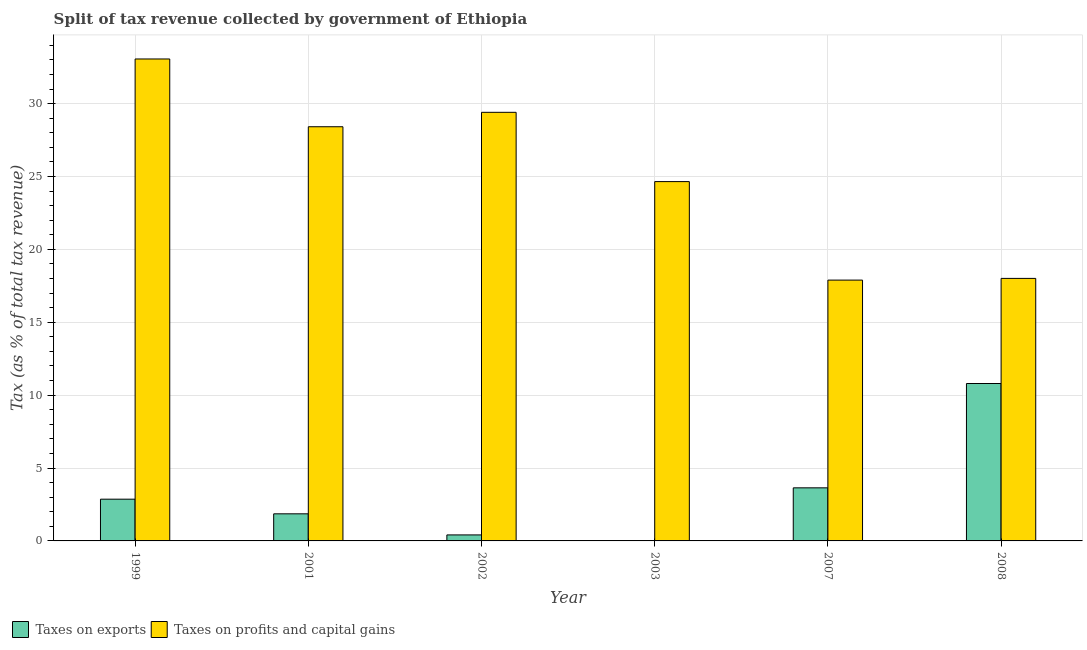How many different coloured bars are there?
Give a very brief answer. 2. Are the number of bars per tick equal to the number of legend labels?
Make the answer very short. Yes. How many bars are there on the 5th tick from the left?
Your response must be concise. 2. In how many cases, is the number of bars for a given year not equal to the number of legend labels?
Provide a succinct answer. 0. What is the percentage of revenue obtained from taxes on exports in 2008?
Keep it short and to the point. 10.8. Across all years, what is the maximum percentage of revenue obtained from taxes on exports?
Provide a short and direct response. 10.8. Across all years, what is the minimum percentage of revenue obtained from taxes on profits and capital gains?
Give a very brief answer. 17.89. In which year was the percentage of revenue obtained from taxes on profits and capital gains maximum?
Your answer should be compact. 1999. In which year was the percentage of revenue obtained from taxes on exports minimum?
Provide a short and direct response. 2003. What is the total percentage of revenue obtained from taxes on exports in the graph?
Keep it short and to the point. 19.59. What is the difference between the percentage of revenue obtained from taxes on exports in 2002 and that in 2007?
Your answer should be compact. -3.23. What is the difference between the percentage of revenue obtained from taxes on exports in 2002 and the percentage of revenue obtained from taxes on profits and capital gains in 2007?
Keep it short and to the point. -3.23. What is the average percentage of revenue obtained from taxes on profits and capital gains per year?
Your response must be concise. 25.24. In the year 2002, what is the difference between the percentage of revenue obtained from taxes on profits and capital gains and percentage of revenue obtained from taxes on exports?
Give a very brief answer. 0. What is the ratio of the percentage of revenue obtained from taxes on exports in 2001 to that in 2003?
Provide a short and direct response. 113.99. Is the difference between the percentage of revenue obtained from taxes on exports in 2002 and 2007 greater than the difference between the percentage of revenue obtained from taxes on profits and capital gains in 2002 and 2007?
Your answer should be very brief. No. What is the difference between the highest and the second highest percentage of revenue obtained from taxes on exports?
Ensure brevity in your answer.  7.16. What is the difference between the highest and the lowest percentage of revenue obtained from taxes on profits and capital gains?
Keep it short and to the point. 15.17. In how many years, is the percentage of revenue obtained from taxes on exports greater than the average percentage of revenue obtained from taxes on exports taken over all years?
Provide a succinct answer. 2. Is the sum of the percentage of revenue obtained from taxes on exports in 2001 and 2007 greater than the maximum percentage of revenue obtained from taxes on profits and capital gains across all years?
Your answer should be compact. No. What does the 1st bar from the left in 2007 represents?
Your response must be concise. Taxes on exports. What does the 2nd bar from the right in 2008 represents?
Your answer should be compact. Taxes on exports. Are all the bars in the graph horizontal?
Offer a terse response. No. Are the values on the major ticks of Y-axis written in scientific E-notation?
Make the answer very short. No. Where does the legend appear in the graph?
Provide a short and direct response. Bottom left. What is the title of the graph?
Offer a terse response. Split of tax revenue collected by government of Ethiopia. Does "From Government" appear as one of the legend labels in the graph?
Your response must be concise. No. What is the label or title of the Y-axis?
Provide a succinct answer. Tax (as % of total tax revenue). What is the Tax (as % of total tax revenue) in Taxes on exports in 1999?
Your answer should be very brief. 2.86. What is the Tax (as % of total tax revenue) in Taxes on profits and capital gains in 1999?
Keep it short and to the point. 33.06. What is the Tax (as % of total tax revenue) of Taxes on exports in 2001?
Offer a terse response. 1.86. What is the Tax (as % of total tax revenue) in Taxes on profits and capital gains in 2001?
Your response must be concise. 28.41. What is the Tax (as % of total tax revenue) in Taxes on exports in 2002?
Your answer should be very brief. 0.41. What is the Tax (as % of total tax revenue) in Taxes on profits and capital gains in 2002?
Offer a very short reply. 29.4. What is the Tax (as % of total tax revenue) in Taxes on exports in 2003?
Your answer should be compact. 0.02. What is the Tax (as % of total tax revenue) of Taxes on profits and capital gains in 2003?
Ensure brevity in your answer.  24.65. What is the Tax (as % of total tax revenue) of Taxes on exports in 2007?
Give a very brief answer. 3.64. What is the Tax (as % of total tax revenue) of Taxes on profits and capital gains in 2007?
Provide a short and direct response. 17.89. What is the Tax (as % of total tax revenue) of Taxes on exports in 2008?
Offer a very short reply. 10.8. What is the Tax (as % of total tax revenue) of Taxes on profits and capital gains in 2008?
Provide a short and direct response. 18.01. Across all years, what is the maximum Tax (as % of total tax revenue) in Taxes on exports?
Give a very brief answer. 10.8. Across all years, what is the maximum Tax (as % of total tax revenue) of Taxes on profits and capital gains?
Give a very brief answer. 33.06. Across all years, what is the minimum Tax (as % of total tax revenue) of Taxes on exports?
Provide a succinct answer. 0.02. Across all years, what is the minimum Tax (as % of total tax revenue) in Taxes on profits and capital gains?
Ensure brevity in your answer.  17.89. What is the total Tax (as % of total tax revenue) in Taxes on exports in the graph?
Ensure brevity in your answer.  19.59. What is the total Tax (as % of total tax revenue) in Taxes on profits and capital gains in the graph?
Your answer should be compact. 151.42. What is the difference between the Tax (as % of total tax revenue) of Taxes on profits and capital gains in 1999 and that in 2001?
Provide a succinct answer. 4.65. What is the difference between the Tax (as % of total tax revenue) in Taxes on exports in 1999 and that in 2002?
Make the answer very short. 2.45. What is the difference between the Tax (as % of total tax revenue) in Taxes on profits and capital gains in 1999 and that in 2002?
Your answer should be very brief. 3.66. What is the difference between the Tax (as % of total tax revenue) of Taxes on exports in 1999 and that in 2003?
Your answer should be compact. 2.85. What is the difference between the Tax (as % of total tax revenue) in Taxes on profits and capital gains in 1999 and that in 2003?
Your answer should be very brief. 8.41. What is the difference between the Tax (as % of total tax revenue) in Taxes on exports in 1999 and that in 2007?
Make the answer very short. -0.78. What is the difference between the Tax (as % of total tax revenue) of Taxes on profits and capital gains in 1999 and that in 2007?
Give a very brief answer. 15.17. What is the difference between the Tax (as % of total tax revenue) of Taxes on exports in 1999 and that in 2008?
Offer a very short reply. -7.93. What is the difference between the Tax (as % of total tax revenue) in Taxes on profits and capital gains in 1999 and that in 2008?
Offer a very short reply. 15.05. What is the difference between the Tax (as % of total tax revenue) of Taxes on exports in 2001 and that in 2002?
Give a very brief answer. 1.45. What is the difference between the Tax (as % of total tax revenue) in Taxes on profits and capital gains in 2001 and that in 2002?
Offer a terse response. -0.99. What is the difference between the Tax (as % of total tax revenue) in Taxes on exports in 2001 and that in 2003?
Ensure brevity in your answer.  1.84. What is the difference between the Tax (as % of total tax revenue) of Taxes on profits and capital gains in 2001 and that in 2003?
Provide a short and direct response. 3.76. What is the difference between the Tax (as % of total tax revenue) in Taxes on exports in 2001 and that in 2007?
Offer a very short reply. -1.78. What is the difference between the Tax (as % of total tax revenue) of Taxes on profits and capital gains in 2001 and that in 2007?
Offer a terse response. 10.52. What is the difference between the Tax (as % of total tax revenue) in Taxes on exports in 2001 and that in 2008?
Keep it short and to the point. -8.94. What is the difference between the Tax (as % of total tax revenue) in Taxes on profits and capital gains in 2001 and that in 2008?
Make the answer very short. 10.4. What is the difference between the Tax (as % of total tax revenue) of Taxes on exports in 2002 and that in 2003?
Give a very brief answer. 0.4. What is the difference between the Tax (as % of total tax revenue) in Taxes on profits and capital gains in 2002 and that in 2003?
Your answer should be compact. 4.75. What is the difference between the Tax (as % of total tax revenue) in Taxes on exports in 2002 and that in 2007?
Provide a succinct answer. -3.23. What is the difference between the Tax (as % of total tax revenue) in Taxes on profits and capital gains in 2002 and that in 2007?
Provide a short and direct response. 11.51. What is the difference between the Tax (as % of total tax revenue) in Taxes on exports in 2002 and that in 2008?
Provide a succinct answer. -10.39. What is the difference between the Tax (as % of total tax revenue) in Taxes on profits and capital gains in 2002 and that in 2008?
Make the answer very short. 11.39. What is the difference between the Tax (as % of total tax revenue) of Taxes on exports in 2003 and that in 2007?
Keep it short and to the point. -3.63. What is the difference between the Tax (as % of total tax revenue) of Taxes on profits and capital gains in 2003 and that in 2007?
Ensure brevity in your answer.  6.76. What is the difference between the Tax (as % of total tax revenue) of Taxes on exports in 2003 and that in 2008?
Offer a very short reply. -10.78. What is the difference between the Tax (as % of total tax revenue) of Taxes on profits and capital gains in 2003 and that in 2008?
Your response must be concise. 6.64. What is the difference between the Tax (as % of total tax revenue) of Taxes on exports in 2007 and that in 2008?
Ensure brevity in your answer.  -7.16. What is the difference between the Tax (as % of total tax revenue) in Taxes on profits and capital gains in 2007 and that in 2008?
Keep it short and to the point. -0.12. What is the difference between the Tax (as % of total tax revenue) of Taxes on exports in 1999 and the Tax (as % of total tax revenue) of Taxes on profits and capital gains in 2001?
Your answer should be very brief. -25.55. What is the difference between the Tax (as % of total tax revenue) in Taxes on exports in 1999 and the Tax (as % of total tax revenue) in Taxes on profits and capital gains in 2002?
Offer a terse response. -26.54. What is the difference between the Tax (as % of total tax revenue) of Taxes on exports in 1999 and the Tax (as % of total tax revenue) of Taxes on profits and capital gains in 2003?
Your answer should be compact. -21.78. What is the difference between the Tax (as % of total tax revenue) in Taxes on exports in 1999 and the Tax (as % of total tax revenue) in Taxes on profits and capital gains in 2007?
Your answer should be compact. -15.03. What is the difference between the Tax (as % of total tax revenue) in Taxes on exports in 1999 and the Tax (as % of total tax revenue) in Taxes on profits and capital gains in 2008?
Your response must be concise. -15.14. What is the difference between the Tax (as % of total tax revenue) of Taxes on exports in 2001 and the Tax (as % of total tax revenue) of Taxes on profits and capital gains in 2002?
Your answer should be very brief. -27.54. What is the difference between the Tax (as % of total tax revenue) of Taxes on exports in 2001 and the Tax (as % of total tax revenue) of Taxes on profits and capital gains in 2003?
Provide a succinct answer. -22.79. What is the difference between the Tax (as % of total tax revenue) in Taxes on exports in 2001 and the Tax (as % of total tax revenue) in Taxes on profits and capital gains in 2007?
Provide a short and direct response. -16.03. What is the difference between the Tax (as % of total tax revenue) of Taxes on exports in 2001 and the Tax (as % of total tax revenue) of Taxes on profits and capital gains in 2008?
Ensure brevity in your answer.  -16.15. What is the difference between the Tax (as % of total tax revenue) in Taxes on exports in 2002 and the Tax (as % of total tax revenue) in Taxes on profits and capital gains in 2003?
Keep it short and to the point. -24.24. What is the difference between the Tax (as % of total tax revenue) in Taxes on exports in 2002 and the Tax (as % of total tax revenue) in Taxes on profits and capital gains in 2007?
Keep it short and to the point. -17.48. What is the difference between the Tax (as % of total tax revenue) of Taxes on exports in 2002 and the Tax (as % of total tax revenue) of Taxes on profits and capital gains in 2008?
Offer a terse response. -17.6. What is the difference between the Tax (as % of total tax revenue) of Taxes on exports in 2003 and the Tax (as % of total tax revenue) of Taxes on profits and capital gains in 2007?
Your response must be concise. -17.88. What is the difference between the Tax (as % of total tax revenue) of Taxes on exports in 2003 and the Tax (as % of total tax revenue) of Taxes on profits and capital gains in 2008?
Ensure brevity in your answer.  -17.99. What is the difference between the Tax (as % of total tax revenue) of Taxes on exports in 2007 and the Tax (as % of total tax revenue) of Taxes on profits and capital gains in 2008?
Give a very brief answer. -14.37. What is the average Tax (as % of total tax revenue) of Taxes on exports per year?
Your answer should be compact. 3.27. What is the average Tax (as % of total tax revenue) in Taxes on profits and capital gains per year?
Provide a short and direct response. 25.24. In the year 1999, what is the difference between the Tax (as % of total tax revenue) in Taxes on exports and Tax (as % of total tax revenue) in Taxes on profits and capital gains?
Ensure brevity in your answer.  -30.2. In the year 2001, what is the difference between the Tax (as % of total tax revenue) in Taxes on exports and Tax (as % of total tax revenue) in Taxes on profits and capital gains?
Keep it short and to the point. -26.55. In the year 2002, what is the difference between the Tax (as % of total tax revenue) of Taxes on exports and Tax (as % of total tax revenue) of Taxes on profits and capital gains?
Your answer should be compact. -28.99. In the year 2003, what is the difference between the Tax (as % of total tax revenue) of Taxes on exports and Tax (as % of total tax revenue) of Taxes on profits and capital gains?
Keep it short and to the point. -24.63. In the year 2007, what is the difference between the Tax (as % of total tax revenue) of Taxes on exports and Tax (as % of total tax revenue) of Taxes on profits and capital gains?
Your response must be concise. -14.25. In the year 2008, what is the difference between the Tax (as % of total tax revenue) in Taxes on exports and Tax (as % of total tax revenue) in Taxes on profits and capital gains?
Give a very brief answer. -7.21. What is the ratio of the Tax (as % of total tax revenue) of Taxes on exports in 1999 to that in 2001?
Provide a short and direct response. 1.54. What is the ratio of the Tax (as % of total tax revenue) in Taxes on profits and capital gains in 1999 to that in 2001?
Provide a short and direct response. 1.16. What is the ratio of the Tax (as % of total tax revenue) in Taxes on exports in 1999 to that in 2002?
Provide a short and direct response. 6.96. What is the ratio of the Tax (as % of total tax revenue) of Taxes on profits and capital gains in 1999 to that in 2002?
Offer a terse response. 1.12. What is the ratio of the Tax (as % of total tax revenue) in Taxes on exports in 1999 to that in 2003?
Provide a short and direct response. 175.63. What is the ratio of the Tax (as % of total tax revenue) of Taxes on profits and capital gains in 1999 to that in 2003?
Your answer should be very brief. 1.34. What is the ratio of the Tax (as % of total tax revenue) of Taxes on exports in 1999 to that in 2007?
Provide a short and direct response. 0.79. What is the ratio of the Tax (as % of total tax revenue) of Taxes on profits and capital gains in 1999 to that in 2007?
Ensure brevity in your answer.  1.85. What is the ratio of the Tax (as % of total tax revenue) in Taxes on exports in 1999 to that in 2008?
Provide a short and direct response. 0.27. What is the ratio of the Tax (as % of total tax revenue) in Taxes on profits and capital gains in 1999 to that in 2008?
Make the answer very short. 1.84. What is the ratio of the Tax (as % of total tax revenue) in Taxes on exports in 2001 to that in 2002?
Give a very brief answer. 4.52. What is the ratio of the Tax (as % of total tax revenue) of Taxes on profits and capital gains in 2001 to that in 2002?
Give a very brief answer. 0.97. What is the ratio of the Tax (as % of total tax revenue) of Taxes on exports in 2001 to that in 2003?
Keep it short and to the point. 113.99. What is the ratio of the Tax (as % of total tax revenue) of Taxes on profits and capital gains in 2001 to that in 2003?
Keep it short and to the point. 1.15. What is the ratio of the Tax (as % of total tax revenue) of Taxes on exports in 2001 to that in 2007?
Provide a short and direct response. 0.51. What is the ratio of the Tax (as % of total tax revenue) of Taxes on profits and capital gains in 2001 to that in 2007?
Your answer should be compact. 1.59. What is the ratio of the Tax (as % of total tax revenue) of Taxes on exports in 2001 to that in 2008?
Provide a succinct answer. 0.17. What is the ratio of the Tax (as % of total tax revenue) in Taxes on profits and capital gains in 2001 to that in 2008?
Provide a short and direct response. 1.58. What is the ratio of the Tax (as % of total tax revenue) in Taxes on exports in 2002 to that in 2003?
Provide a succinct answer. 25.24. What is the ratio of the Tax (as % of total tax revenue) in Taxes on profits and capital gains in 2002 to that in 2003?
Your answer should be very brief. 1.19. What is the ratio of the Tax (as % of total tax revenue) in Taxes on exports in 2002 to that in 2007?
Ensure brevity in your answer.  0.11. What is the ratio of the Tax (as % of total tax revenue) of Taxes on profits and capital gains in 2002 to that in 2007?
Offer a very short reply. 1.64. What is the ratio of the Tax (as % of total tax revenue) in Taxes on exports in 2002 to that in 2008?
Your answer should be compact. 0.04. What is the ratio of the Tax (as % of total tax revenue) of Taxes on profits and capital gains in 2002 to that in 2008?
Ensure brevity in your answer.  1.63. What is the ratio of the Tax (as % of total tax revenue) in Taxes on exports in 2003 to that in 2007?
Ensure brevity in your answer.  0. What is the ratio of the Tax (as % of total tax revenue) in Taxes on profits and capital gains in 2003 to that in 2007?
Offer a very short reply. 1.38. What is the ratio of the Tax (as % of total tax revenue) of Taxes on exports in 2003 to that in 2008?
Your answer should be compact. 0. What is the ratio of the Tax (as % of total tax revenue) of Taxes on profits and capital gains in 2003 to that in 2008?
Ensure brevity in your answer.  1.37. What is the ratio of the Tax (as % of total tax revenue) of Taxes on exports in 2007 to that in 2008?
Make the answer very short. 0.34. What is the ratio of the Tax (as % of total tax revenue) in Taxes on profits and capital gains in 2007 to that in 2008?
Your response must be concise. 0.99. What is the difference between the highest and the second highest Tax (as % of total tax revenue) of Taxes on exports?
Offer a terse response. 7.16. What is the difference between the highest and the second highest Tax (as % of total tax revenue) in Taxes on profits and capital gains?
Offer a very short reply. 3.66. What is the difference between the highest and the lowest Tax (as % of total tax revenue) in Taxes on exports?
Keep it short and to the point. 10.78. What is the difference between the highest and the lowest Tax (as % of total tax revenue) in Taxes on profits and capital gains?
Your answer should be very brief. 15.17. 